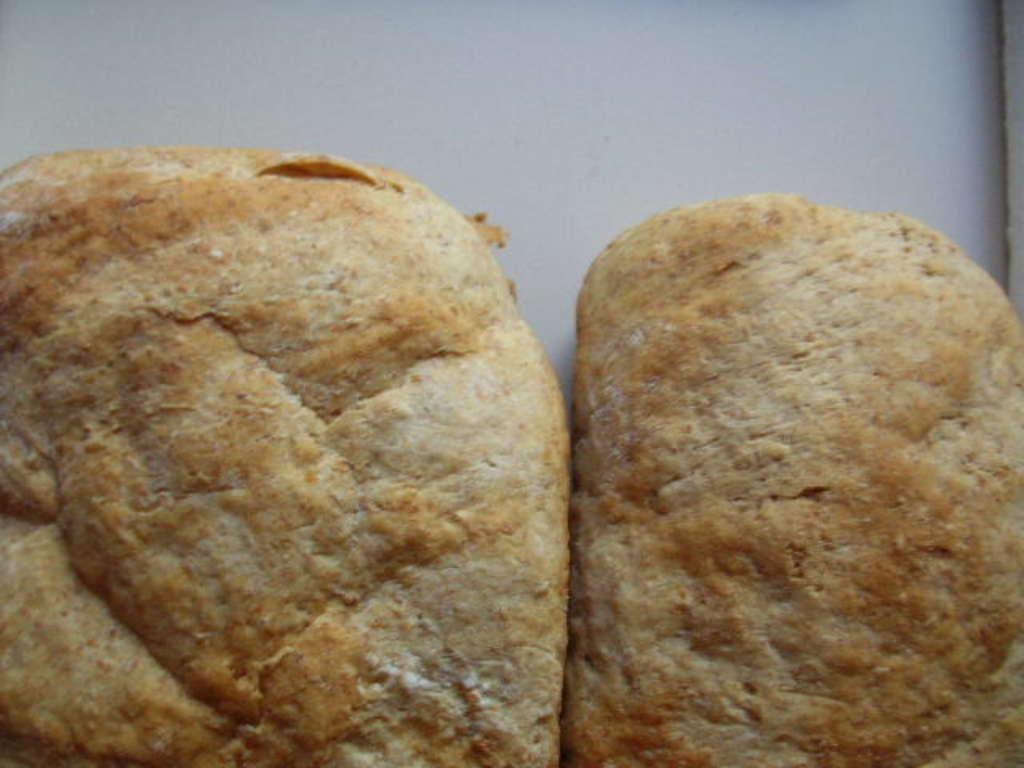Describe this image in one or two sentences. There is some object in the center of the image. 